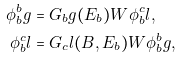Convert formula to latex. <formula><loc_0><loc_0><loc_500><loc_500>\phi _ { b } ^ { b } g & = G _ { b } g ( E _ { b } ) W \phi _ { b } ^ { c } l , \\ \phi _ { b } ^ { c } l & = G _ { c } l ( B , E _ { b } ) W \phi _ { b } ^ { b } g ,</formula> 